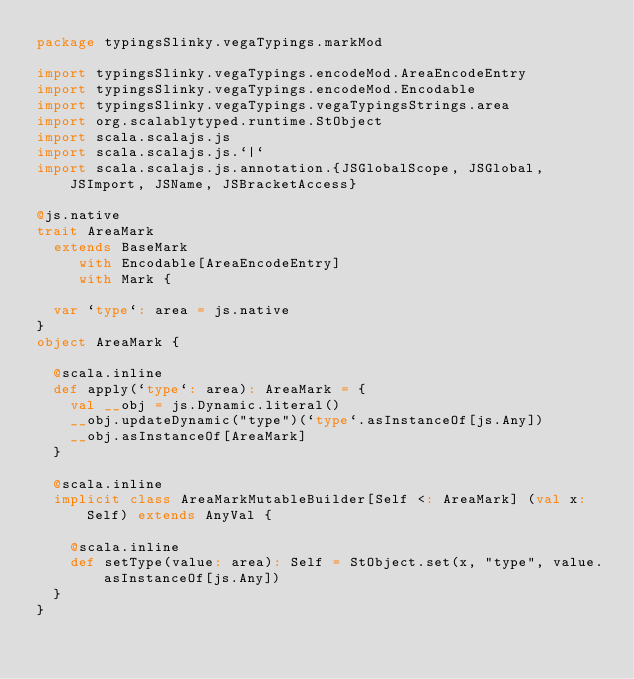<code> <loc_0><loc_0><loc_500><loc_500><_Scala_>package typingsSlinky.vegaTypings.markMod

import typingsSlinky.vegaTypings.encodeMod.AreaEncodeEntry
import typingsSlinky.vegaTypings.encodeMod.Encodable
import typingsSlinky.vegaTypings.vegaTypingsStrings.area
import org.scalablytyped.runtime.StObject
import scala.scalajs.js
import scala.scalajs.js.`|`
import scala.scalajs.js.annotation.{JSGlobalScope, JSGlobal, JSImport, JSName, JSBracketAccess}

@js.native
trait AreaMark
  extends BaseMark
     with Encodable[AreaEncodeEntry]
     with Mark {
  
  var `type`: area = js.native
}
object AreaMark {
  
  @scala.inline
  def apply(`type`: area): AreaMark = {
    val __obj = js.Dynamic.literal()
    __obj.updateDynamic("type")(`type`.asInstanceOf[js.Any])
    __obj.asInstanceOf[AreaMark]
  }
  
  @scala.inline
  implicit class AreaMarkMutableBuilder[Self <: AreaMark] (val x: Self) extends AnyVal {
    
    @scala.inline
    def setType(value: area): Self = StObject.set(x, "type", value.asInstanceOf[js.Any])
  }
}
</code> 